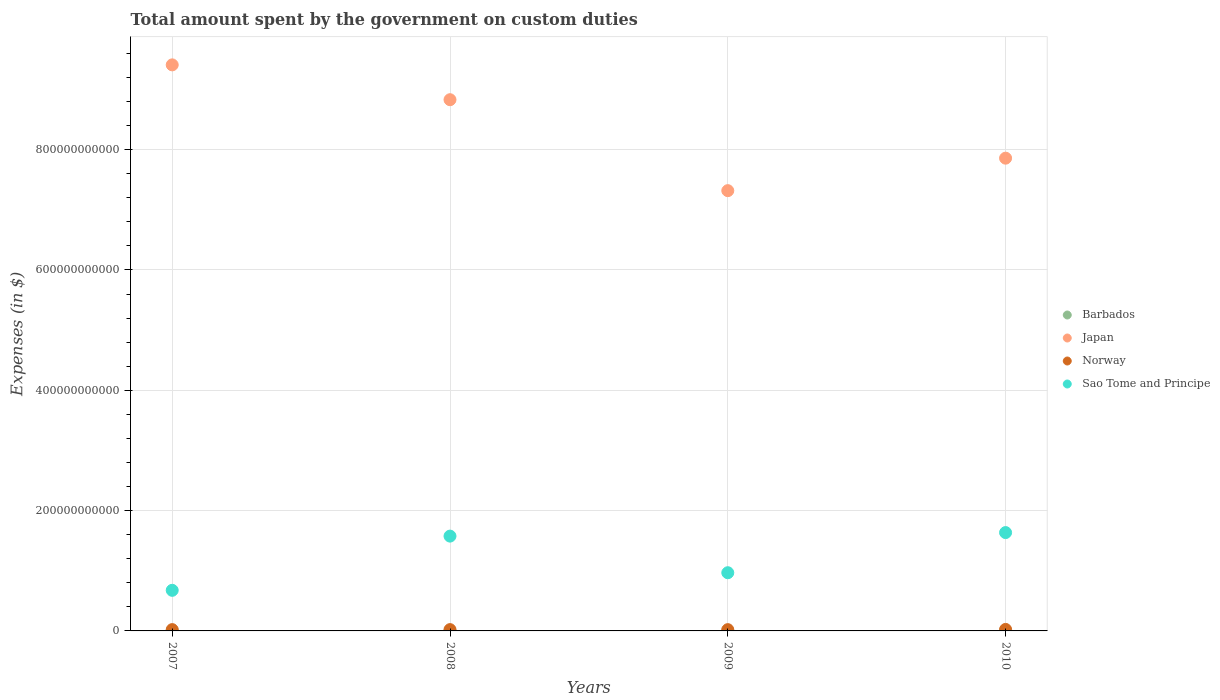How many different coloured dotlines are there?
Provide a short and direct response. 4. Is the number of dotlines equal to the number of legend labels?
Make the answer very short. Yes. What is the amount spent on custom duties by the government in Barbados in 2010?
Provide a short and direct response. 1.91e+08. Across all years, what is the maximum amount spent on custom duties by the government in Barbados?
Offer a terse response. 2.19e+08. Across all years, what is the minimum amount spent on custom duties by the government in Japan?
Make the answer very short. 7.32e+11. What is the total amount spent on custom duties by the government in Norway in the graph?
Keep it short and to the point. 8.96e+09. What is the difference between the amount spent on custom duties by the government in Sao Tome and Principe in 2007 and that in 2009?
Provide a succinct answer. -2.93e+1. What is the difference between the amount spent on custom duties by the government in Norway in 2009 and the amount spent on custom duties by the government in Japan in 2008?
Provide a short and direct response. -8.81e+11. What is the average amount spent on custom duties by the government in Barbados per year?
Provide a succinct answer. 2.01e+08. In the year 2007, what is the difference between the amount spent on custom duties by the government in Japan and amount spent on custom duties by the government in Barbados?
Ensure brevity in your answer.  9.41e+11. In how many years, is the amount spent on custom duties by the government in Barbados greater than 560000000000 $?
Ensure brevity in your answer.  0. What is the ratio of the amount spent on custom duties by the government in Sao Tome and Principe in 2007 to that in 2008?
Make the answer very short. 0.43. Is the difference between the amount spent on custom duties by the government in Japan in 2008 and 2010 greater than the difference between the amount spent on custom duties by the government in Barbados in 2008 and 2010?
Ensure brevity in your answer.  Yes. What is the difference between the highest and the second highest amount spent on custom duties by the government in Japan?
Your response must be concise. 5.79e+1. What is the difference between the highest and the lowest amount spent on custom duties by the government in Barbados?
Offer a very short reply. 4.15e+07. In how many years, is the amount spent on custom duties by the government in Japan greater than the average amount spent on custom duties by the government in Japan taken over all years?
Make the answer very short. 2. Is it the case that in every year, the sum of the amount spent on custom duties by the government in Barbados and amount spent on custom duties by the government in Norway  is greater than the sum of amount spent on custom duties by the government in Japan and amount spent on custom duties by the government in Sao Tome and Principe?
Give a very brief answer. Yes. Is it the case that in every year, the sum of the amount spent on custom duties by the government in Norway and amount spent on custom duties by the government in Japan  is greater than the amount spent on custom duties by the government in Barbados?
Keep it short and to the point. Yes. Does the amount spent on custom duties by the government in Japan monotonically increase over the years?
Offer a very short reply. No. Is the amount spent on custom duties by the government in Sao Tome and Principe strictly greater than the amount spent on custom duties by the government in Norway over the years?
Offer a very short reply. Yes. Is the amount spent on custom duties by the government in Barbados strictly less than the amount spent on custom duties by the government in Sao Tome and Principe over the years?
Ensure brevity in your answer.  Yes. How many dotlines are there?
Keep it short and to the point. 4. How many years are there in the graph?
Offer a terse response. 4. What is the difference between two consecutive major ticks on the Y-axis?
Keep it short and to the point. 2.00e+11. Are the values on the major ticks of Y-axis written in scientific E-notation?
Offer a very short reply. No. Does the graph contain grids?
Your answer should be compact. Yes. How many legend labels are there?
Offer a terse response. 4. How are the legend labels stacked?
Provide a short and direct response. Vertical. What is the title of the graph?
Make the answer very short. Total amount spent by the government on custom duties. What is the label or title of the Y-axis?
Provide a succinct answer. Expenses (in $). What is the Expenses (in $) of Barbados in 2007?
Your answer should be compact. 2.17e+08. What is the Expenses (in $) of Japan in 2007?
Keep it short and to the point. 9.41e+11. What is the Expenses (in $) of Norway in 2007?
Ensure brevity in your answer.  2.17e+09. What is the Expenses (in $) in Sao Tome and Principe in 2007?
Your response must be concise. 6.75e+1. What is the Expenses (in $) of Barbados in 2008?
Your answer should be compact. 2.19e+08. What is the Expenses (in $) in Japan in 2008?
Offer a terse response. 8.83e+11. What is the Expenses (in $) in Norway in 2008?
Keep it short and to the point. 2.17e+09. What is the Expenses (in $) of Sao Tome and Principe in 2008?
Give a very brief answer. 1.58e+11. What is the Expenses (in $) in Barbados in 2009?
Your answer should be compact. 1.78e+08. What is the Expenses (in $) of Japan in 2009?
Your answer should be compact. 7.32e+11. What is the Expenses (in $) in Norway in 2009?
Provide a short and direct response. 2.12e+09. What is the Expenses (in $) in Sao Tome and Principe in 2009?
Your answer should be compact. 9.67e+1. What is the Expenses (in $) in Barbados in 2010?
Keep it short and to the point. 1.91e+08. What is the Expenses (in $) of Japan in 2010?
Your answer should be very brief. 7.86e+11. What is the Expenses (in $) in Norway in 2010?
Offer a terse response. 2.50e+09. What is the Expenses (in $) in Sao Tome and Principe in 2010?
Your response must be concise. 1.63e+11. Across all years, what is the maximum Expenses (in $) in Barbados?
Provide a succinct answer. 2.19e+08. Across all years, what is the maximum Expenses (in $) of Japan?
Provide a short and direct response. 9.41e+11. Across all years, what is the maximum Expenses (in $) in Norway?
Keep it short and to the point. 2.50e+09. Across all years, what is the maximum Expenses (in $) in Sao Tome and Principe?
Provide a short and direct response. 1.63e+11. Across all years, what is the minimum Expenses (in $) in Barbados?
Your answer should be compact. 1.78e+08. Across all years, what is the minimum Expenses (in $) in Japan?
Make the answer very short. 7.32e+11. Across all years, what is the minimum Expenses (in $) in Norway?
Keep it short and to the point. 2.12e+09. Across all years, what is the minimum Expenses (in $) of Sao Tome and Principe?
Give a very brief answer. 6.75e+1. What is the total Expenses (in $) of Barbados in the graph?
Make the answer very short. 8.05e+08. What is the total Expenses (in $) of Japan in the graph?
Make the answer very short. 3.34e+12. What is the total Expenses (in $) in Norway in the graph?
Offer a very short reply. 8.96e+09. What is the total Expenses (in $) of Sao Tome and Principe in the graph?
Keep it short and to the point. 4.85e+11. What is the difference between the Expenses (in $) in Barbados in 2007 and that in 2008?
Your answer should be compact. -2.52e+06. What is the difference between the Expenses (in $) in Japan in 2007 and that in 2008?
Your response must be concise. 5.79e+1. What is the difference between the Expenses (in $) in Sao Tome and Principe in 2007 and that in 2008?
Offer a terse response. -9.01e+1. What is the difference between the Expenses (in $) in Barbados in 2007 and that in 2009?
Provide a succinct answer. 3.90e+07. What is the difference between the Expenses (in $) in Japan in 2007 and that in 2009?
Make the answer very short. 2.09e+11. What is the difference between the Expenses (in $) in Sao Tome and Principe in 2007 and that in 2009?
Your answer should be compact. -2.93e+1. What is the difference between the Expenses (in $) of Barbados in 2007 and that in 2010?
Your answer should be compact. 2.61e+07. What is the difference between the Expenses (in $) of Japan in 2007 and that in 2010?
Provide a succinct answer. 1.55e+11. What is the difference between the Expenses (in $) in Norway in 2007 and that in 2010?
Offer a terse response. -3.30e+08. What is the difference between the Expenses (in $) of Sao Tome and Principe in 2007 and that in 2010?
Offer a terse response. -9.60e+1. What is the difference between the Expenses (in $) in Barbados in 2008 and that in 2009?
Offer a terse response. 4.15e+07. What is the difference between the Expenses (in $) of Japan in 2008 and that in 2009?
Your response must be concise. 1.51e+11. What is the difference between the Expenses (in $) of Norway in 2008 and that in 2009?
Give a very brief answer. 5.00e+07. What is the difference between the Expenses (in $) in Sao Tome and Principe in 2008 and that in 2009?
Offer a very short reply. 6.09e+1. What is the difference between the Expenses (in $) of Barbados in 2008 and that in 2010?
Offer a very short reply. 2.87e+07. What is the difference between the Expenses (in $) of Japan in 2008 and that in 2010?
Offer a very short reply. 9.72e+1. What is the difference between the Expenses (in $) in Norway in 2008 and that in 2010?
Give a very brief answer. -3.30e+08. What is the difference between the Expenses (in $) of Sao Tome and Principe in 2008 and that in 2010?
Make the answer very short. -5.86e+09. What is the difference between the Expenses (in $) of Barbados in 2009 and that in 2010?
Provide a succinct answer. -1.28e+07. What is the difference between the Expenses (in $) in Japan in 2009 and that in 2010?
Offer a very short reply. -5.40e+1. What is the difference between the Expenses (in $) in Norway in 2009 and that in 2010?
Provide a short and direct response. -3.80e+08. What is the difference between the Expenses (in $) in Sao Tome and Principe in 2009 and that in 2010?
Keep it short and to the point. -6.67e+1. What is the difference between the Expenses (in $) in Barbados in 2007 and the Expenses (in $) in Japan in 2008?
Give a very brief answer. -8.83e+11. What is the difference between the Expenses (in $) in Barbados in 2007 and the Expenses (in $) in Norway in 2008?
Provide a short and direct response. -1.95e+09. What is the difference between the Expenses (in $) of Barbados in 2007 and the Expenses (in $) of Sao Tome and Principe in 2008?
Offer a very short reply. -1.57e+11. What is the difference between the Expenses (in $) in Japan in 2007 and the Expenses (in $) in Norway in 2008?
Provide a succinct answer. 9.39e+11. What is the difference between the Expenses (in $) in Japan in 2007 and the Expenses (in $) in Sao Tome and Principe in 2008?
Keep it short and to the point. 7.83e+11. What is the difference between the Expenses (in $) of Norway in 2007 and the Expenses (in $) of Sao Tome and Principe in 2008?
Provide a succinct answer. -1.55e+11. What is the difference between the Expenses (in $) in Barbados in 2007 and the Expenses (in $) in Japan in 2009?
Provide a succinct answer. -7.32e+11. What is the difference between the Expenses (in $) of Barbados in 2007 and the Expenses (in $) of Norway in 2009?
Your response must be concise. -1.90e+09. What is the difference between the Expenses (in $) of Barbados in 2007 and the Expenses (in $) of Sao Tome and Principe in 2009?
Your response must be concise. -9.65e+1. What is the difference between the Expenses (in $) in Japan in 2007 and the Expenses (in $) in Norway in 2009?
Your response must be concise. 9.39e+11. What is the difference between the Expenses (in $) of Japan in 2007 and the Expenses (in $) of Sao Tome and Principe in 2009?
Your answer should be very brief. 8.44e+11. What is the difference between the Expenses (in $) of Norway in 2007 and the Expenses (in $) of Sao Tome and Principe in 2009?
Ensure brevity in your answer.  -9.46e+1. What is the difference between the Expenses (in $) in Barbados in 2007 and the Expenses (in $) in Japan in 2010?
Keep it short and to the point. -7.86e+11. What is the difference between the Expenses (in $) in Barbados in 2007 and the Expenses (in $) in Norway in 2010?
Your answer should be very brief. -2.28e+09. What is the difference between the Expenses (in $) in Barbados in 2007 and the Expenses (in $) in Sao Tome and Principe in 2010?
Your answer should be compact. -1.63e+11. What is the difference between the Expenses (in $) in Japan in 2007 and the Expenses (in $) in Norway in 2010?
Keep it short and to the point. 9.38e+11. What is the difference between the Expenses (in $) of Japan in 2007 and the Expenses (in $) of Sao Tome and Principe in 2010?
Offer a very short reply. 7.78e+11. What is the difference between the Expenses (in $) in Norway in 2007 and the Expenses (in $) in Sao Tome and Principe in 2010?
Provide a succinct answer. -1.61e+11. What is the difference between the Expenses (in $) in Barbados in 2008 and the Expenses (in $) in Japan in 2009?
Give a very brief answer. -7.32e+11. What is the difference between the Expenses (in $) in Barbados in 2008 and the Expenses (in $) in Norway in 2009?
Give a very brief answer. -1.90e+09. What is the difference between the Expenses (in $) of Barbados in 2008 and the Expenses (in $) of Sao Tome and Principe in 2009?
Provide a short and direct response. -9.65e+1. What is the difference between the Expenses (in $) in Japan in 2008 and the Expenses (in $) in Norway in 2009?
Provide a short and direct response. 8.81e+11. What is the difference between the Expenses (in $) of Japan in 2008 and the Expenses (in $) of Sao Tome and Principe in 2009?
Make the answer very short. 7.86e+11. What is the difference between the Expenses (in $) in Norway in 2008 and the Expenses (in $) in Sao Tome and Principe in 2009?
Make the answer very short. -9.46e+1. What is the difference between the Expenses (in $) of Barbados in 2008 and the Expenses (in $) of Japan in 2010?
Provide a short and direct response. -7.86e+11. What is the difference between the Expenses (in $) of Barbados in 2008 and the Expenses (in $) of Norway in 2010?
Your response must be concise. -2.28e+09. What is the difference between the Expenses (in $) in Barbados in 2008 and the Expenses (in $) in Sao Tome and Principe in 2010?
Your response must be concise. -1.63e+11. What is the difference between the Expenses (in $) of Japan in 2008 and the Expenses (in $) of Norway in 2010?
Your answer should be very brief. 8.81e+11. What is the difference between the Expenses (in $) in Japan in 2008 and the Expenses (in $) in Sao Tome and Principe in 2010?
Offer a terse response. 7.20e+11. What is the difference between the Expenses (in $) of Norway in 2008 and the Expenses (in $) of Sao Tome and Principe in 2010?
Your answer should be compact. -1.61e+11. What is the difference between the Expenses (in $) of Barbados in 2009 and the Expenses (in $) of Japan in 2010?
Your answer should be compact. -7.86e+11. What is the difference between the Expenses (in $) in Barbados in 2009 and the Expenses (in $) in Norway in 2010?
Provide a succinct answer. -2.32e+09. What is the difference between the Expenses (in $) of Barbados in 2009 and the Expenses (in $) of Sao Tome and Principe in 2010?
Provide a succinct answer. -1.63e+11. What is the difference between the Expenses (in $) in Japan in 2009 and the Expenses (in $) in Norway in 2010?
Give a very brief answer. 7.29e+11. What is the difference between the Expenses (in $) in Japan in 2009 and the Expenses (in $) in Sao Tome and Principe in 2010?
Provide a succinct answer. 5.68e+11. What is the difference between the Expenses (in $) in Norway in 2009 and the Expenses (in $) in Sao Tome and Principe in 2010?
Keep it short and to the point. -1.61e+11. What is the average Expenses (in $) in Barbados per year?
Make the answer very short. 2.01e+08. What is the average Expenses (in $) of Japan per year?
Offer a terse response. 8.35e+11. What is the average Expenses (in $) of Norway per year?
Offer a very short reply. 2.24e+09. What is the average Expenses (in $) of Sao Tome and Principe per year?
Keep it short and to the point. 1.21e+11. In the year 2007, what is the difference between the Expenses (in $) in Barbados and Expenses (in $) in Japan?
Your answer should be very brief. -9.41e+11. In the year 2007, what is the difference between the Expenses (in $) in Barbados and Expenses (in $) in Norway?
Your answer should be very brief. -1.95e+09. In the year 2007, what is the difference between the Expenses (in $) in Barbados and Expenses (in $) in Sao Tome and Principe?
Keep it short and to the point. -6.73e+1. In the year 2007, what is the difference between the Expenses (in $) of Japan and Expenses (in $) of Norway?
Make the answer very short. 9.39e+11. In the year 2007, what is the difference between the Expenses (in $) in Japan and Expenses (in $) in Sao Tome and Principe?
Your response must be concise. 8.74e+11. In the year 2007, what is the difference between the Expenses (in $) in Norway and Expenses (in $) in Sao Tome and Principe?
Your answer should be very brief. -6.53e+1. In the year 2008, what is the difference between the Expenses (in $) in Barbados and Expenses (in $) in Japan?
Your answer should be very brief. -8.83e+11. In the year 2008, what is the difference between the Expenses (in $) of Barbados and Expenses (in $) of Norway?
Your answer should be compact. -1.95e+09. In the year 2008, what is the difference between the Expenses (in $) in Barbados and Expenses (in $) in Sao Tome and Principe?
Your answer should be very brief. -1.57e+11. In the year 2008, what is the difference between the Expenses (in $) of Japan and Expenses (in $) of Norway?
Offer a terse response. 8.81e+11. In the year 2008, what is the difference between the Expenses (in $) of Japan and Expenses (in $) of Sao Tome and Principe?
Offer a very short reply. 7.25e+11. In the year 2008, what is the difference between the Expenses (in $) of Norway and Expenses (in $) of Sao Tome and Principe?
Provide a short and direct response. -1.55e+11. In the year 2009, what is the difference between the Expenses (in $) of Barbados and Expenses (in $) of Japan?
Ensure brevity in your answer.  -7.32e+11. In the year 2009, what is the difference between the Expenses (in $) in Barbados and Expenses (in $) in Norway?
Offer a terse response. -1.94e+09. In the year 2009, what is the difference between the Expenses (in $) in Barbados and Expenses (in $) in Sao Tome and Principe?
Provide a short and direct response. -9.66e+1. In the year 2009, what is the difference between the Expenses (in $) in Japan and Expenses (in $) in Norway?
Ensure brevity in your answer.  7.30e+11. In the year 2009, what is the difference between the Expenses (in $) of Japan and Expenses (in $) of Sao Tome and Principe?
Offer a terse response. 6.35e+11. In the year 2009, what is the difference between the Expenses (in $) in Norway and Expenses (in $) in Sao Tome and Principe?
Offer a terse response. -9.46e+1. In the year 2010, what is the difference between the Expenses (in $) of Barbados and Expenses (in $) of Japan?
Your answer should be very brief. -7.86e+11. In the year 2010, what is the difference between the Expenses (in $) in Barbados and Expenses (in $) in Norway?
Your response must be concise. -2.31e+09. In the year 2010, what is the difference between the Expenses (in $) in Barbados and Expenses (in $) in Sao Tome and Principe?
Give a very brief answer. -1.63e+11. In the year 2010, what is the difference between the Expenses (in $) in Japan and Expenses (in $) in Norway?
Ensure brevity in your answer.  7.83e+11. In the year 2010, what is the difference between the Expenses (in $) in Japan and Expenses (in $) in Sao Tome and Principe?
Offer a terse response. 6.22e+11. In the year 2010, what is the difference between the Expenses (in $) of Norway and Expenses (in $) of Sao Tome and Principe?
Provide a short and direct response. -1.61e+11. What is the ratio of the Expenses (in $) in Barbados in 2007 to that in 2008?
Provide a succinct answer. 0.99. What is the ratio of the Expenses (in $) in Japan in 2007 to that in 2008?
Ensure brevity in your answer.  1.07. What is the ratio of the Expenses (in $) in Norway in 2007 to that in 2008?
Keep it short and to the point. 1. What is the ratio of the Expenses (in $) of Sao Tome and Principe in 2007 to that in 2008?
Your answer should be very brief. 0.43. What is the ratio of the Expenses (in $) in Barbados in 2007 to that in 2009?
Provide a short and direct response. 1.22. What is the ratio of the Expenses (in $) of Norway in 2007 to that in 2009?
Provide a succinct answer. 1.02. What is the ratio of the Expenses (in $) of Sao Tome and Principe in 2007 to that in 2009?
Offer a terse response. 0.7. What is the ratio of the Expenses (in $) of Barbados in 2007 to that in 2010?
Provide a short and direct response. 1.14. What is the ratio of the Expenses (in $) of Japan in 2007 to that in 2010?
Offer a very short reply. 1.2. What is the ratio of the Expenses (in $) of Norway in 2007 to that in 2010?
Offer a terse response. 0.87. What is the ratio of the Expenses (in $) of Sao Tome and Principe in 2007 to that in 2010?
Give a very brief answer. 0.41. What is the ratio of the Expenses (in $) of Barbados in 2008 to that in 2009?
Your answer should be very brief. 1.23. What is the ratio of the Expenses (in $) of Japan in 2008 to that in 2009?
Give a very brief answer. 1.21. What is the ratio of the Expenses (in $) in Norway in 2008 to that in 2009?
Make the answer very short. 1.02. What is the ratio of the Expenses (in $) of Sao Tome and Principe in 2008 to that in 2009?
Your answer should be very brief. 1.63. What is the ratio of the Expenses (in $) in Barbados in 2008 to that in 2010?
Ensure brevity in your answer.  1.15. What is the ratio of the Expenses (in $) of Japan in 2008 to that in 2010?
Give a very brief answer. 1.12. What is the ratio of the Expenses (in $) of Norway in 2008 to that in 2010?
Provide a short and direct response. 0.87. What is the ratio of the Expenses (in $) in Sao Tome and Principe in 2008 to that in 2010?
Provide a succinct answer. 0.96. What is the ratio of the Expenses (in $) of Barbados in 2009 to that in 2010?
Ensure brevity in your answer.  0.93. What is the ratio of the Expenses (in $) of Japan in 2009 to that in 2010?
Offer a terse response. 0.93. What is the ratio of the Expenses (in $) in Norway in 2009 to that in 2010?
Your answer should be very brief. 0.85. What is the ratio of the Expenses (in $) in Sao Tome and Principe in 2009 to that in 2010?
Ensure brevity in your answer.  0.59. What is the difference between the highest and the second highest Expenses (in $) in Barbados?
Your answer should be compact. 2.52e+06. What is the difference between the highest and the second highest Expenses (in $) of Japan?
Provide a succinct answer. 5.79e+1. What is the difference between the highest and the second highest Expenses (in $) in Norway?
Offer a terse response. 3.30e+08. What is the difference between the highest and the second highest Expenses (in $) in Sao Tome and Principe?
Your answer should be compact. 5.86e+09. What is the difference between the highest and the lowest Expenses (in $) in Barbados?
Make the answer very short. 4.15e+07. What is the difference between the highest and the lowest Expenses (in $) of Japan?
Your answer should be compact. 2.09e+11. What is the difference between the highest and the lowest Expenses (in $) in Norway?
Your answer should be compact. 3.80e+08. What is the difference between the highest and the lowest Expenses (in $) in Sao Tome and Principe?
Make the answer very short. 9.60e+1. 